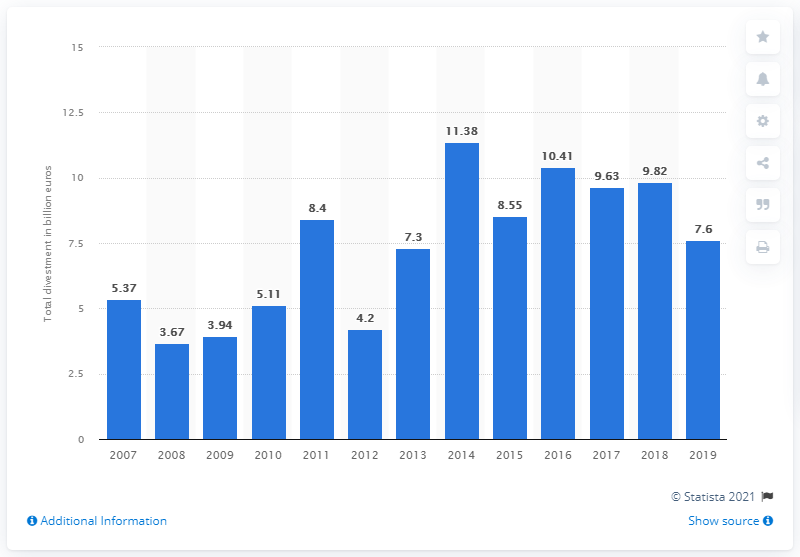List a handful of essential elements in this visual. In 2014, the total value of private equity divestments was 11.38. 